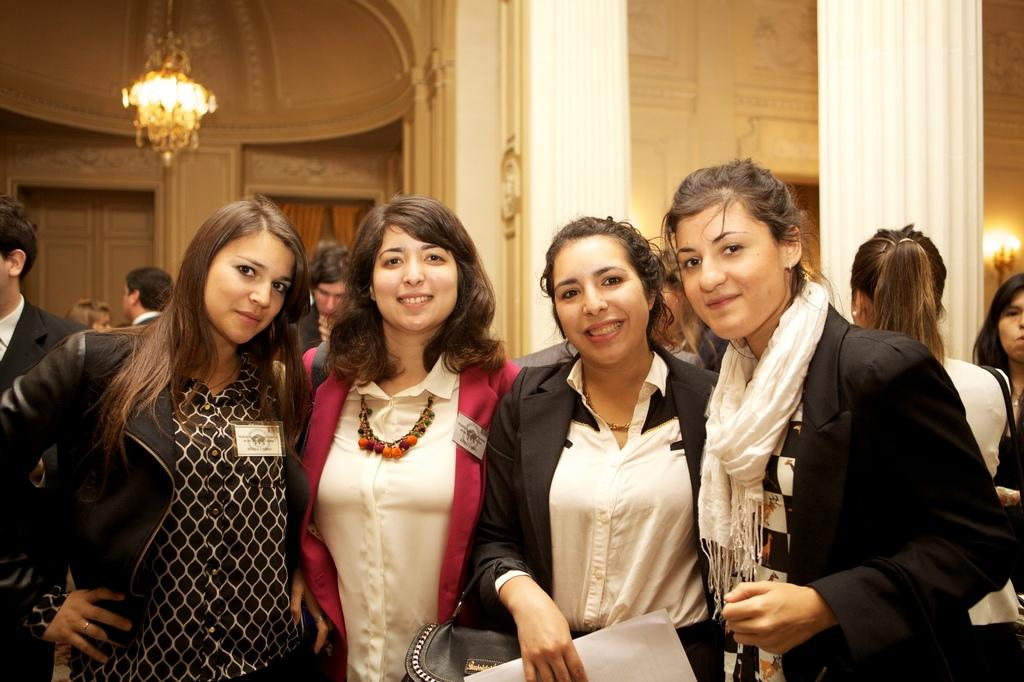What are the people in the image doing? Some of the people are taking pictures. Can you describe the setting of the image? There are many people visible in the background of the image. What is the size of the mountain in the image? There is no mountain present in the image. Is the poison visible in the image? There is no poison present in the image. 